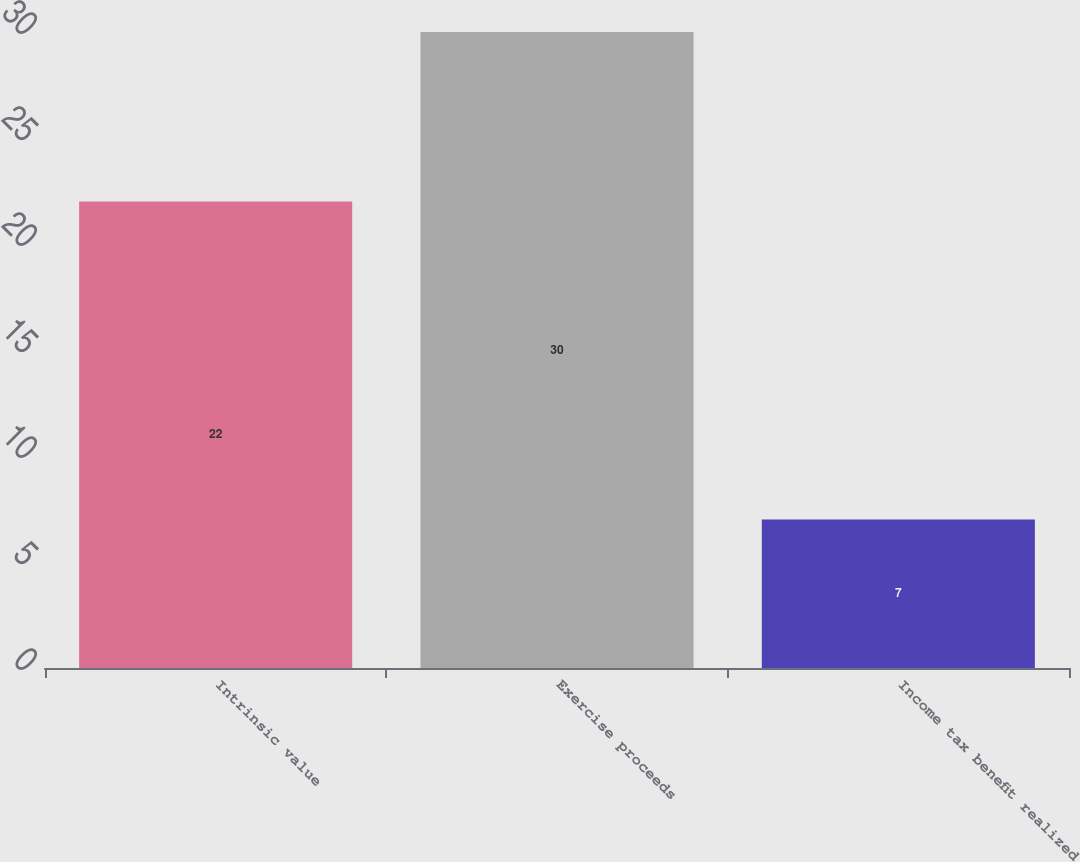Convert chart. <chart><loc_0><loc_0><loc_500><loc_500><bar_chart><fcel>Intrinsic value<fcel>Exercise proceeds<fcel>Income tax benefit realized<nl><fcel>22<fcel>30<fcel>7<nl></chart> 